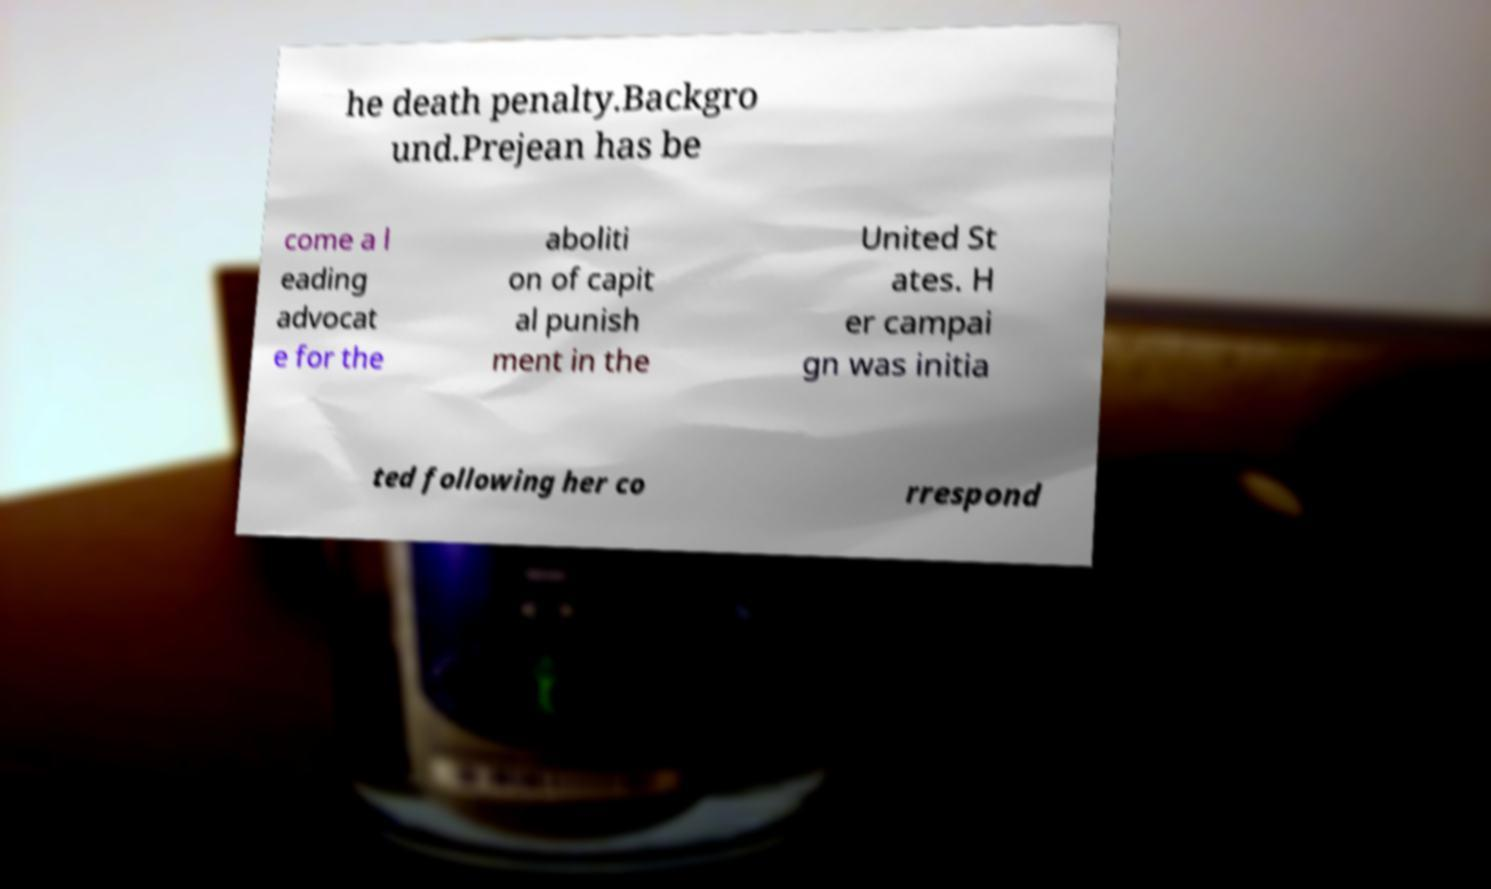Can you accurately transcribe the text from the provided image for me? he death penalty.Backgro und.Prejean has be come a l eading advocat e for the aboliti on of capit al punish ment in the United St ates. H er campai gn was initia ted following her co rrespond 